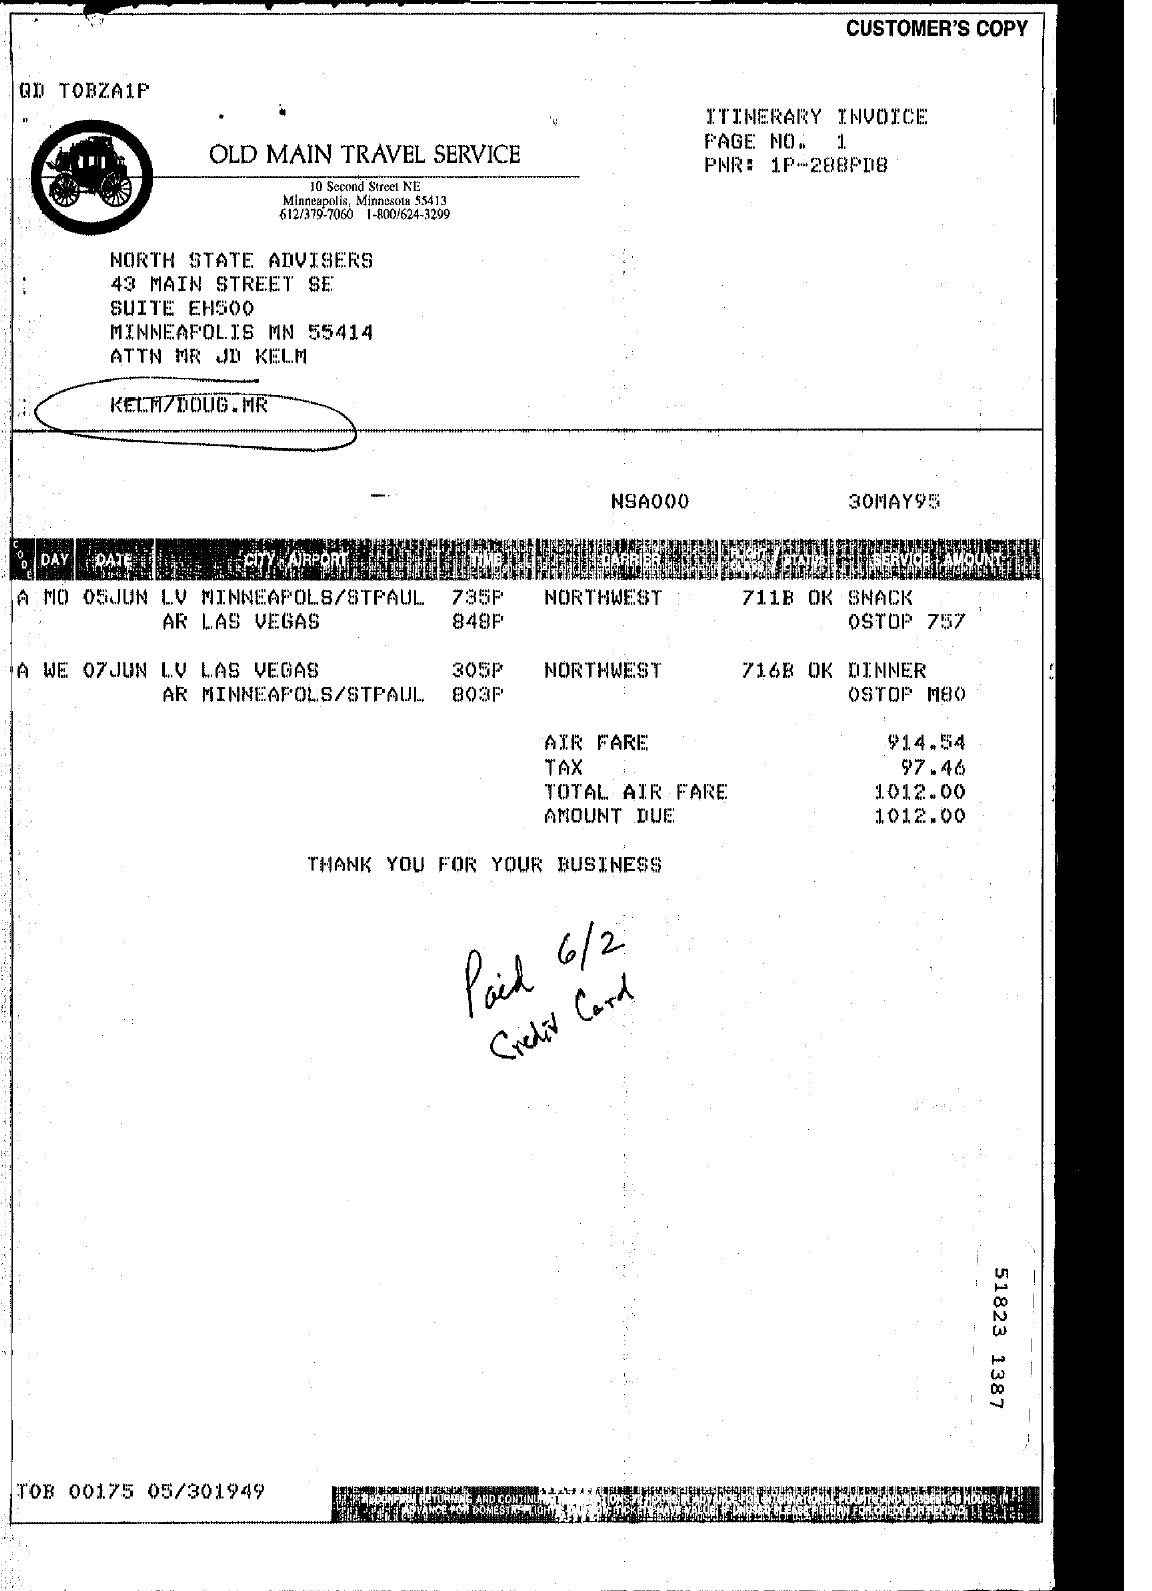Identify some key points in this picture. What is the amount due? It is 1012... 